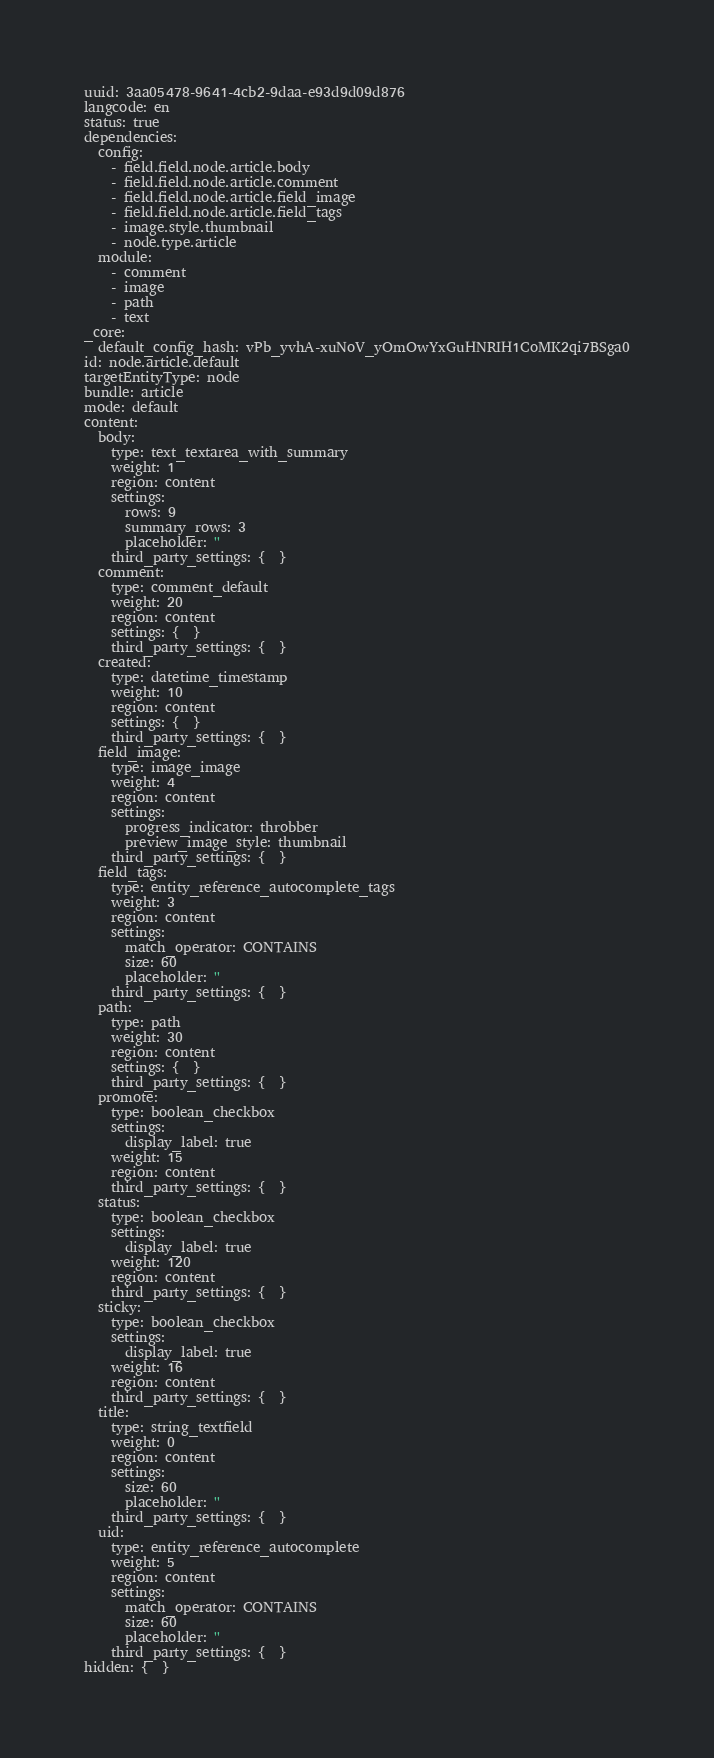<code> <loc_0><loc_0><loc_500><loc_500><_YAML_>uuid: 3aa05478-9641-4cb2-9daa-e93d9d09d876
langcode: en
status: true
dependencies:
  config:
    - field.field.node.article.body
    - field.field.node.article.comment
    - field.field.node.article.field_image
    - field.field.node.article.field_tags
    - image.style.thumbnail
    - node.type.article
  module:
    - comment
    - image
    - path
    - text
_core:
  default_config_hash: vPb_yvhA-xuNoV_yOmOwYxGuHNRIH1CoMK2qi7BSga0
id: node.article.default
targetEntityType: node
bundle: article
mode: default
content:
  body:
    type: text_textarea_with_summary
    weight: 1
    region: content
    settings:
      rows: 9
      summary_rows: 3
      placeholder: ''
    third_party_settings: {  }
  comment:
    type: comment_default
    weight: 20
    region: content
    settings: {  }
    third_party_settings: {  }
  created:
    type: datetime_timestamp
    weight: 10
    region: content
    settings: {  }
    third_party_settings: {  }
  field_image:
    type: image_image
    weight: 4
    region: content
    settings:
      progress_indicator: throbber
      preview_image_style: thumbnail
    third_party_settings: {  }
  field_tags:
    type: entity_reference_autocomplete_tags
    weight: 3
    region: content
    settings:
      match_operator: CONTAINS
      size: 60
      placeholder: ''
    third_party_settings: {  }
  path:
    type: path
    weight: 30
    region: content
    settings: {  }
    third_party_settings: {  }
  promote:
    type: boolean_checkbox
    settings:
      display_label: true
    weight: 15
    region: content
    third_party_settings: {  }
  status:
    type: boolean_checkbox
    settings:
      display_label: true
    weight: 120
    region: content
    third_party_settings: {  }
  sticky:
    type: boolean_checkbox
    settings:
      display_label: true
    weight: 16
    region: content
    third_party_settings: {  }
  title:
    type: string_textfield
    weight: 0
    region: content
    settings:
      size: 60
      placeholder: ''
    third_party_settings: {  }
  uid:
    type: entity_reference_autocomplete
    weight: 5
    region: content
    settings:
      match_operator: CONTAINS
      size: 60
      placeholder: ''
    third_party_settings: {  }
hidden: {  }
</code> 